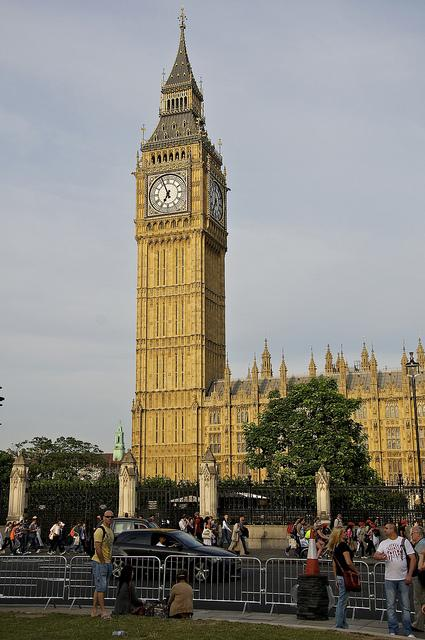The clock is reading five minutes before which hour?

Choices:
A) eleven
B) twelve
C) seven
D) eight seven 